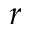Convert formula to latex. <formula><loc_0><loc_0><loc_500><loc_500>r</formula> 